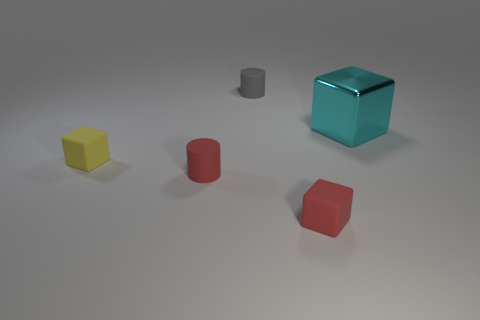Subtract all blue cubes. Subtract all blue balls. How many cubes are left? 3 Add 4 big blue shiny cubes. How many objects exist? 9 Subtract all cubes. How many objects are left? 2 Subtract 0 green cylinders. How many objects are left? 5 Subtract all small cylinders. Subtract all red rubber blocks. How many objects are left? 2 Add 4 cyan cubes. How many cyan cubes are left? 5 Add 1 cyan blocks. How many cyan blocks exist? 2 